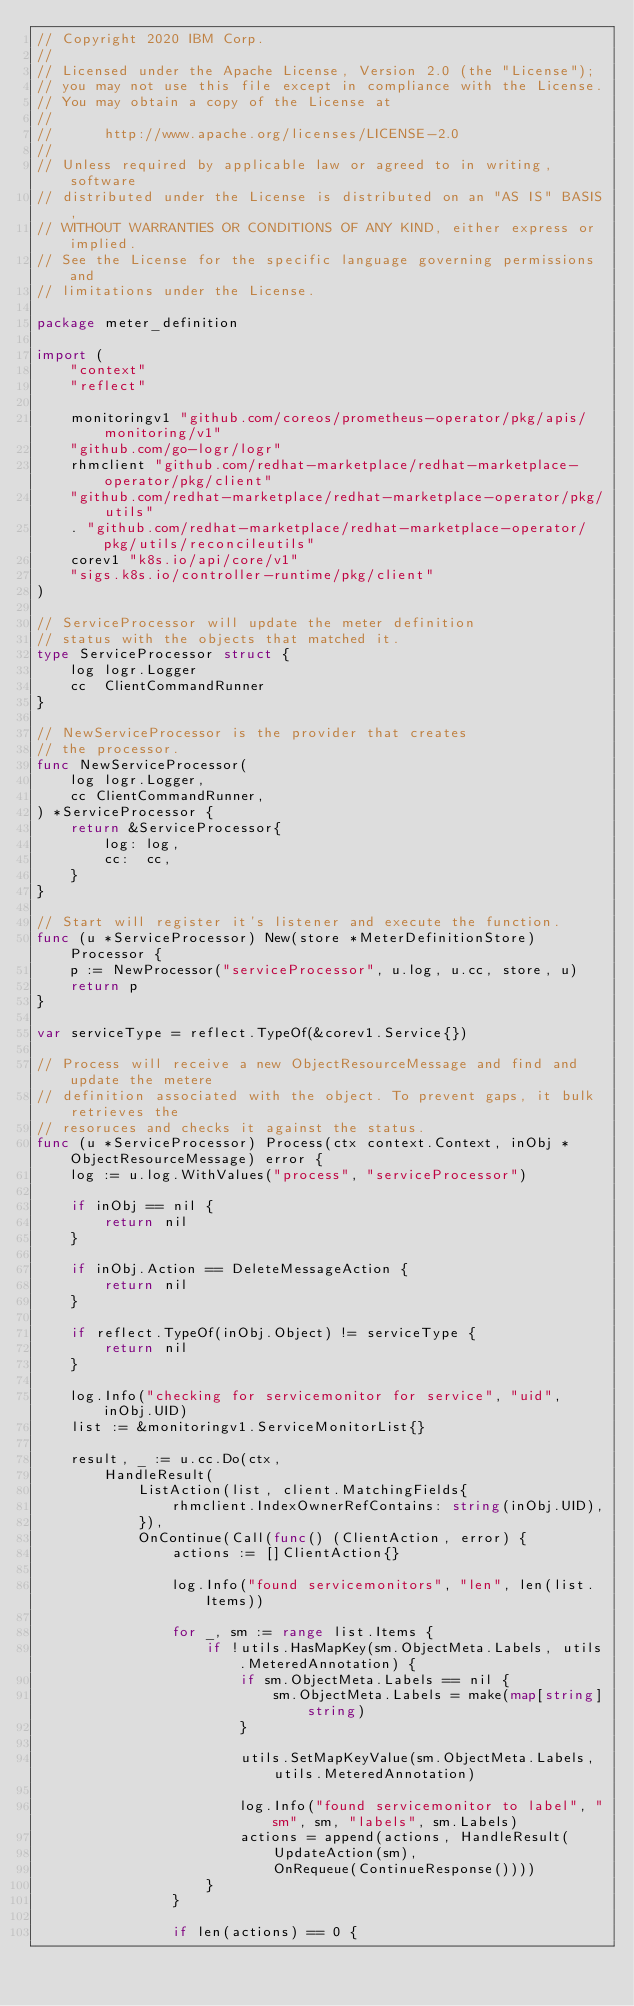Convert code to text. <code><loc_0><loc_0><loc_500><loc_500><_Go_>// Copyright 2020 IBM Corp.
//
// Licensed under the Apache License, Version 2.0 (the "License");
// you may not use this file except in compliance with the License.
// You may obtain a copy of the License at
//
//      http://www.apache.org/licenses/LICENSE-2.0
//
// Unless required by applicable law or agreed to in writing, software
// distributed under the License is distributed on an "AS IS" BASIS,
// WITHOUT WARRANTIES OR CONDITIONS OF ANY KIND, either express or implied.
// See the License for the specific language governing permissions and
// limitations under the License.

package meter_definition

import (
	"context"
	"reflect"

	monitoringv1 "github.com/coreos/prometheus-operator/pkg/apis/monitoring/v1"
	"github.com/go-logr/logr"
	rhmclient "github.com/redhat-marketplace/redhat-marketplace-operator/pkg/client"
	"github.com/redhat-marketplace/redhat-marketplace-operator/pkg/utils"
	. "github.com/redhat-marketplace/redhat-marketplace-operator/pkg/utils/reconcileutils"
	corev1 "k8s.io/api/core/v1"
	"sigs.k8s.io/controller-runtime/pkg/client"
)

// ServiceProcessor will update the meter definition
// status with the objects that matched it.
type ServiceProcessor struct {
	log logr.Logger
	cc  ClientCommandRunner
}

// NewServiceProcessor is the provider that creates
// the processor.
func NewServiceProcessor(
	log logr.Logger,
	cc ClientCommandRunner,
) *ServiceProcessor {
	return &ServiceProcessor{
		log: log,
		cc:  cc,
	}
}

// Start will register it's listener and execute the function.
func (u *ServiceProcessor) New(store *MeterDefinitionStore) Processor {
	p := NewProcessor("serviceProcessor", u.log, u.cc, store, u)
	return p
}

var serviceType = reflect.TypeOf(&corev1.Service{})

// Process will receive a new ObjectResourceMessage and find and update the metere
// definition associated with the object. To prevent gaps, it bulk retrieves the
// resoruces and checks it against the status.
func (u *ServiceProcessor) Process(ctx context.Context, inObj *ObjectResourceMessage) error {
	log := u.log.WithValues("process", "serviceProcessor")

	if inObj == nil {
		return nil
	}

	if inObj.Action == DeleteMessageAction {
		return nil
	}

	if reflect.TypeOf(inObj.Object) != serviceType {
		return nil
	}

	log.Info("checking for servicemonitor for service", "uid", inObj.UID)
	list := &monitoringv1.ServiceMonitorList{}

	result, _ := u.cc.Do(ctx,
		HandleResult(
			ListAction(list, client.MatchingFields{
				rhmclient.IndexOwnerRefContains: string(inObj.UID),
			}),
			OnContinue(Call(func() (ClientAction, error) {
				actions := []ClientAction{}

				log.Info("found servicemonitors", "len", len(list.Items))

				for _, sm := range list.Items {
					if !utils.HasMapKey(sm.ObjectMeta.Labels, utils.MeteredAnnotation) {
						if sm.ObjectMeta.Labels == nil {
							sm.ObjectMeta.Labels = make(map[string]string)
						}

						utils.SetMapKeyValue(sm.ObjectMeta.Labels, utils.MeteredAnnotation)

						log.Info("found servicemonitor to label", "sm", sm, "labels", sm.Labels)
						actions = append(actions, HandleResult(
							UpdateAction(sm),
							OnRequeue(ContinueResponse())))
					}
				}

				if len(actions) == 0 {</code> 